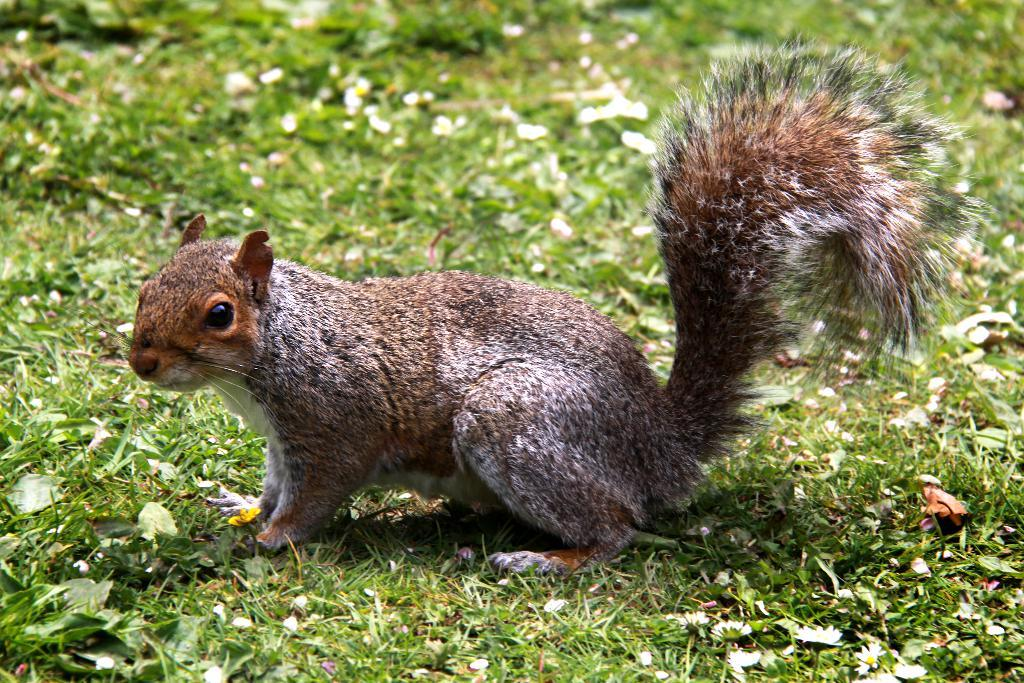What type of animal is in the image? There is a squirrel in the image. What is the squirrel standing on in the image? The squirrel is standing on a grassland. Where is the bun hiding in the image? There is no bun present in the image. What type of structure does the squirrel use to build its nest in the image? The image does not show the squirrel building a nest. 